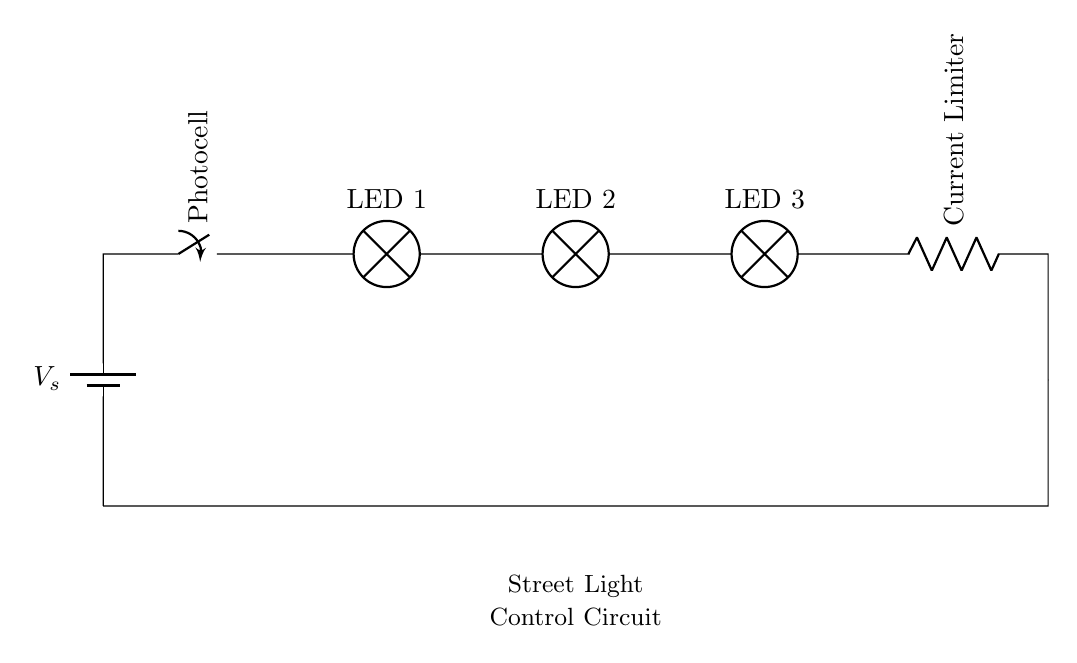What is the primary function of the photocell in this circuit? The photocell acts as a light sensor, controlling the switch to turn the street lights on or off based on ambient light levels.
Answer: Light sensor What are the components of this series circuit? The components are a battery, photocell, three LED lamps, and a current limiter.
Answer: Battery, photocell, LEDs, current limiter How many LED lamps are included in the circuit? There are three LED lamps connected in series.
Answer: Three What happens to the current in the circuit if one LED fails? In a series circuit, if one LED fails, the entire circuit becomes open, and current cannot flow, causing all LEDs to turn off.
Answer: All off Which component limits the current flowing through the LEDs? The current limiter is the component responsible for ensuring that the current does not exceed a safe level for the LEDs.
Answer: Current limiter What is the role of the battery in this circuit? The battery provides the necessary voltage and current to power the circuit and illuminate the LEDs.
Answer: Power source 